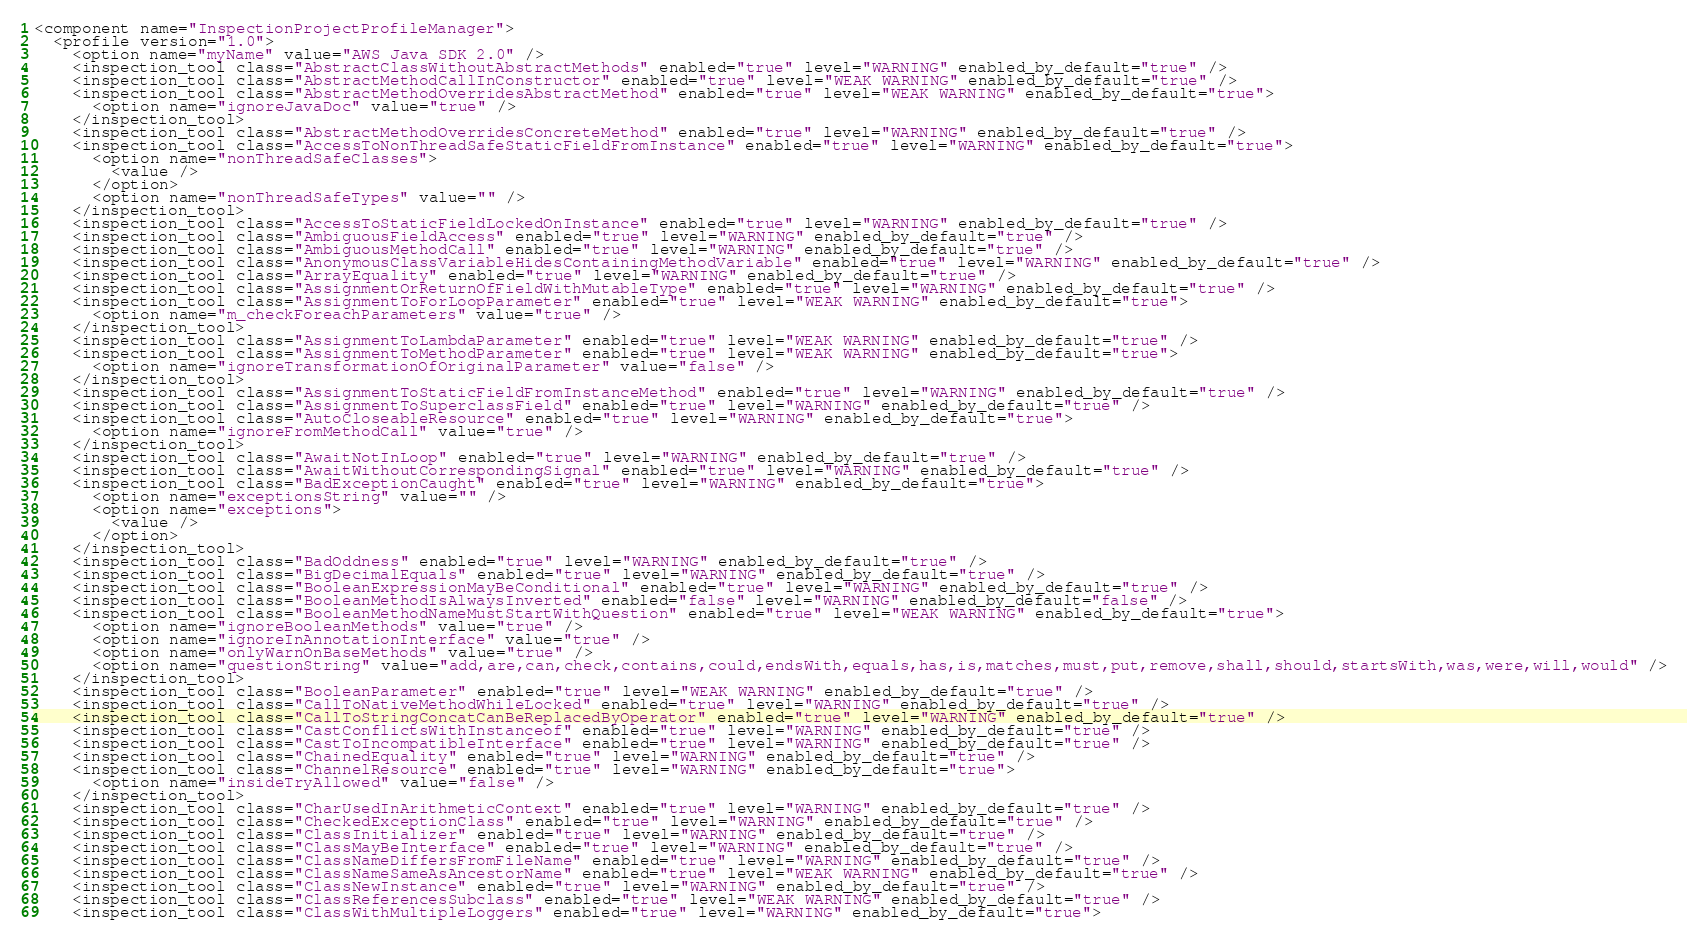<code> <loc_0><loc_0><loc_500><loc_500><_XML_><component name="InspectionProjectProfileManager">
  <profile version="1.0">
    <option name="myName" value="AWS Java SDK 2.0" />
    <inspection_tool class="AbstractClassWithoutAbstractMethods" enabled="true" level="WARNING" enabled_by_default="true" />
    <inspection_tool class="AbstractMethodCallInConstructor" enabled="true" level="WEAK WARNING" enabled_by_default="true" />
    <inspection_tool class="AbstractMethodOverridesAbstractMethod" enabled="true" level="WEAK WARNING" enabled_by_default="true">
      <option name="ignoreJavaDoc" value="true" />
    </inspection_tool>
    <inspection_tool class="AbstractMethodOverridesConcreteMethod" enabled="true" level="WARNING" enabled_by_default="true" />
    <inspection_tool class="AccessToNonThreadSafeStaticFieldFromInstance" enabled="true" level="WARNING" enabled_by_default="true">
      <option name="nonThreadSafeClasses">
        <value />
      </option>
      <option name="nonThreadSafeTypes" value="" />
    </inspection_tool>
    <inspection_tool class="AccessToStaticFieldLockedOnInstance" enabled="true" level="WARNING" enabled_by_default="true" />
    <inspection_tool class="AmbiguousFieldAccess" enabled="true" level="WARNING" enabled_by_default="true" />
    <inspection_tool class="AmbiguousMethodCall" enabled="true" level="WARNING" enabled_by_default="true" />
    <inspection_tool class="AnonymousClassVariableHidesContainingMethodVariable" enabled="true" level="WARNING" enabled_by_default="true" />
    <inspection_tool class="ArrayEquality" enabled="true" level="WARNING" enabled_by_default="true" />
    <inspection_tool class="AssignmentOrReturnOfFieldWithMutableType" enabled="true" level="WARNING" enabled_by_default="true" />
    <inspection_tool class="AssignmentToForLoopParameter" enabled="true" level="WEAK WARNING" enabled_by_default="true">
      <option name="m_checkForeachParameters" value="true" />
    </inspection_tool>
    <inspection_tool class="AssignmentToLambdaParameter" enabled="true" level="WEAK WARNING" enabled_by_default="true" />
    <inspection_tool class="AssignmentToMethodParameter" enabled="true" level="WEAK WARNING" enabled_by_default="true">
      <option name="ignoreTransformationOfOriginalParameter" value="false" />
    </inspection_tool>
    <inspection_tool class="AssignmentToStaticFieldFromInstanceMethod" enabled="true" level="WARNING" enabled_by_default="true" />
    <inspection_tool class="AssignmentToSuperclassField" enabled="true" level="WARNING" enabled_by_default="true" />
    <inspection_tool class="AutoCloseableResource" enabled="true" level="WARNING" enabled_by_default="true">
      <option name="ignoreFromMethodCall" value="true" />
    </inspection_tool>
    <inspection_tool class="AwaitNotInLoop" enabled="true" level="WARNING" enabled_by_default="true" />
    <inspection_tool class="AwaitWithoutCorrespondingSignal" enabled="true" level="WARNING" enabled_by_default="true" />
    <inspection_tool class="BadExceptionCaught" enabled="true" level="WARNING" enabled_by_default="true">
      <option name="exceptionsString" value="" />
      <option name="exceptions">
        <value />
      </option>
    </inspection_tool>
    <inspection_tool class="BadOddness" enabled="true" level="WARNING" enabled_by_default="true" />
    <inspection_tool class="BigDecimalEquals" enabled="true" level="WARNING" enabled_by_default="true" />
    <inspection_tool class="BooleanExpressionMayBeConditional" enabled="true" level="WARNING" enabled_by_default="true" />
    <inspection_tool class="BooleanMethodIsAlwaysInverted" enabled="false" level="WARNING" enabled_by_default="false" />
    <inspection_tool class="BooleanMethodNameMustStartWithQuestion" enabled="true" level="WEAK WARNING" enabled_by_default="true">
      <option name="ignoreBooleanMethods" value="true" />
      <option name="ignoreInAnnotationInterface" value="true" />
      <option name="onlyWarnOnBaseMethods" value="true" />
      <option name="questionString" value="add,are,can,check,contains,could,endsWith,equals,has,is,matches,must,put,remove,shall,should,startsWith,was,were,will,would" />
    </inspection_tool>
    <inspection_tool class="BooleanParameter" enabled="true" level="WEAK WARNING" enabled_by_default="true" />
    <inspection_tool class="CallToNativeMethodWhileLocked" enabled="true" level="WARNING" enabled_by_default="true" />
    <inspection_tool class="CallToStringConcatCanBeReplacedByOperator" enabled="true" level="WARNING" enabled_by_default="true" />
    <inspection_tool class="CastConflictsWithInstanceof" enabled="true" level="WARNING" enabled_by_default="true" />
    <inspection_tool class="CastToIncompatibleInterface" enabled="true" level="WARNING" enabled_by_default="true" />
    <inspection_tool class="ChainedEquality" enabled="true" level="WARNING" enabled_by_default="true" />
    <inspection_tool class="ChannelResource" enabled="true" level="WARNING" enabled_by_default="true">
      <option name="insideTryAllowed" value="false" />
    </inspection_tool>
    <inspection_tool class="CharUsedInArithmeticContext" enabled="true" level="WARNING" enabled_by_default="true" />
    <inspection_tool class="CheckedExceptionClass" enabled="true" level="WARNING" enabled_by_default="true" />
    <inspection_tool class="ClassInitializer" enabled="true" level="WARNING" enabled_by_default="true" />
    <inspection_tool class="ClassMayBeInterface" enabled="true" level="WARNING" enabled_by_default="true" />
    <inspection_tool class="ClassNameDiffersFromFileName" enabled="true" level="WARNING" enabled_by_default="true" />
    <inspection_tool class="ClassNameSameAsAncestorName" enabled="true" level="WEAK WARNING" enabled_by_default="true" />
    <inspection_tool class="ClassNewInstance" enabled="true" level="WARNING" enabled_by_default="true" />
    <inspection_tool class="ClassReferencesSubclass" enabled="true" level="WEAK WARNING" enabled_by_default="true" />
    <inspection_tool class="ClassWithMultipleLoggers" enabled="true" level="WARNING" enabled_by_default="true"></code> 